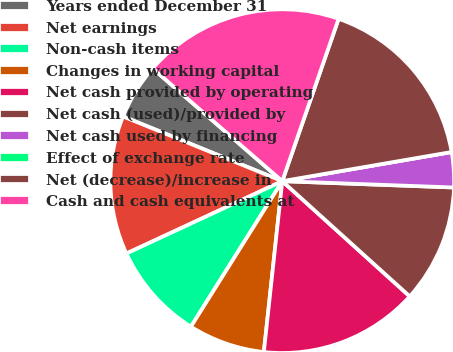Convert chart to OTSL. <chart><loc_0><loc_0><loc_500><loc_500><pie_chart><fcel>Years ended December 31<fcel>Net earnings<fcel>Non-cash items<fcel>Changes in working capital<fcel>Net cash provided by operating<fcel>Net cash (used)/provided by<fcel>Net cash used by financing<fcel>Effect of exchange rate<fcel>Net (decrease)/increase in<fcel>Cash and cash equivalents at<nl><fcel>5.25%<fcel>13.06%<fcel>9.16%<fcel>7.21%<fcel>15.01%<fcel>11.11%<fcel>3.3%<fcel>0.0%<fcel>16.97%<fcel>18.92%<nl></chart> 